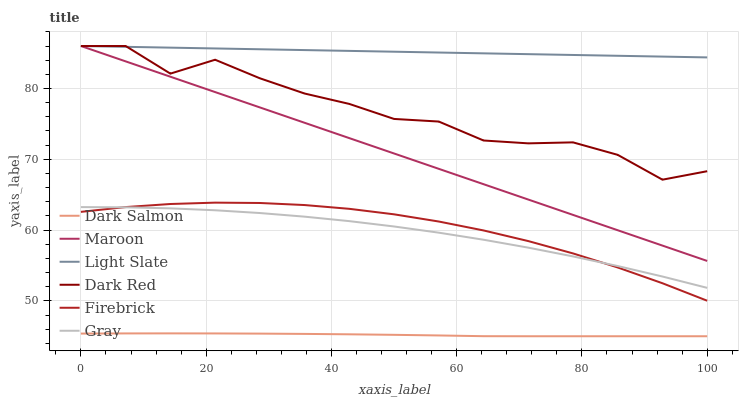Does Dark Salmon have the minimum area under the curve?
Answer yes or no. Yes. Does Light Slate have the maximum area under the curve?
Answer yes or no. Yes. Does Dark Red have the minimum area under the curve?
Answer yes or no. No. Does Dark Red have the maximum area under the curve?
Answer yes or no. No. Is Light Slate the smoothest?
Answer yes or no. Yes. Is Dark Red the roughest?
Answer yes or no. Yes. Is Dark Red the smoothest?
Answer yes or no. No. Is Light Slate the roughest?
Answer yes or no. No. Does Dark Salmon have the lowest value?
Answer yes or no. Yes. Does Dark Red have the lowest value?
Answer yes or no. No. Does Maroon have the highest value?
Answer yes or no. Yes. Does Firebrick have the highest value?
Answer yes or no. No. Is Firebrick less than Dark Red?
Answer yes or no. Yes. Is Gray greater than Dark Salmon?
Answer yes or no. Yes. Does Light Slate intersect Maroon?
Answer yes or no. Yes. Is Light Slate less than Maroon?
Answer yes or no. No. Is Light Slate greater than Maroon?
Answer yes or no. No. Does Firebrick intersect Dark Red?
Answer yes or no. No. 